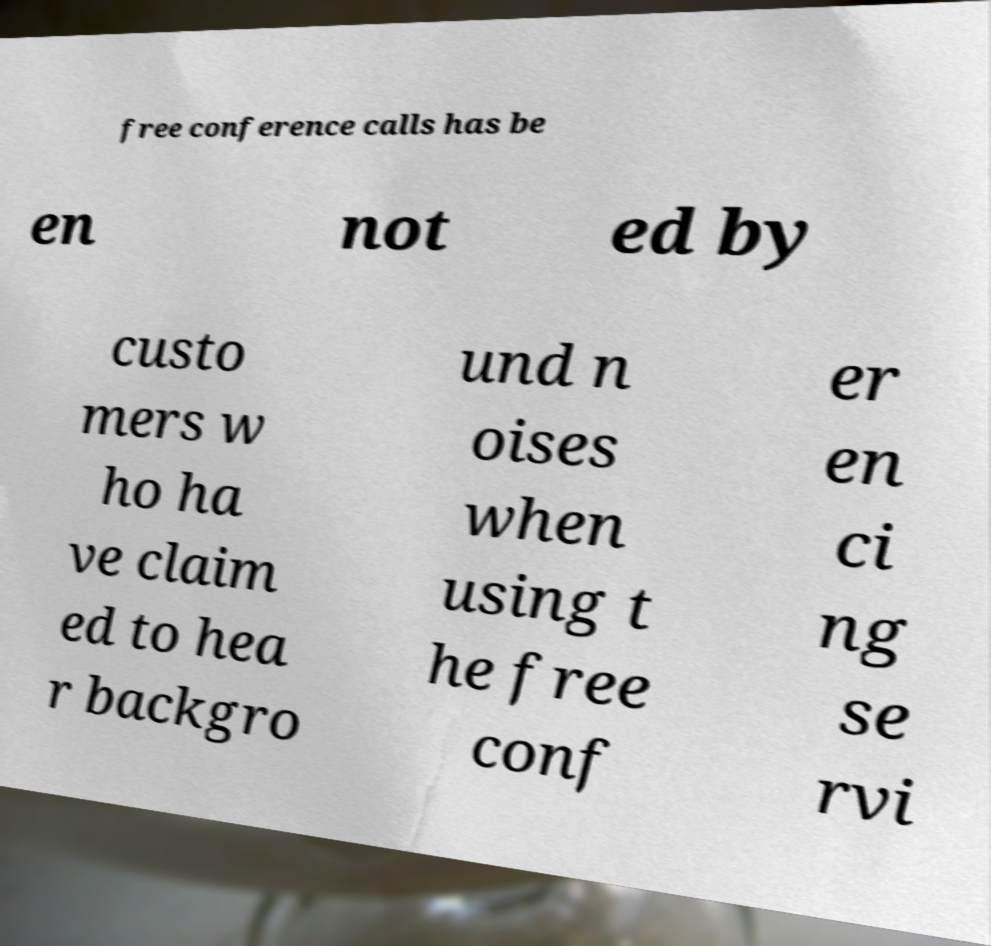Please read and relay the text visible in this image. What does it say? free conference calls has be en not ed by custo mers w ho ha ve claim ed to hea r backgro und n oises when using t he free conf er en ci ng se rvi 